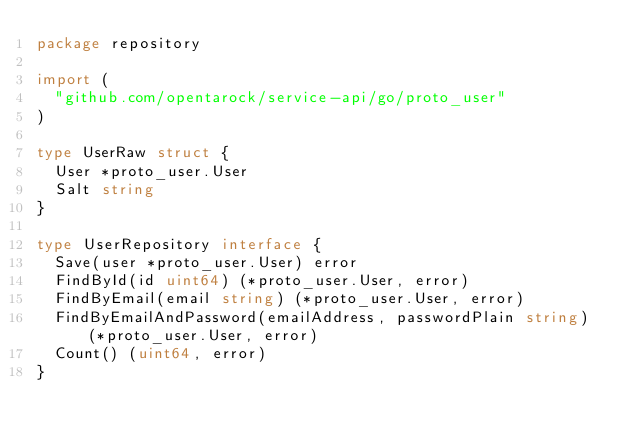Convert code to text. <code><loc_0><loc_0><loc_500><loc_500><_Go_>package repository

import (
	"github.com/opentarock/service-api/go/proto_user"
)

type UserRaw struct {
	User *proto_user.User
	Salt string
}

type UserRepository interface {
	Save(user *proto_user.User) error
	FindById(id uint64) (*proto_user.User, error)
	FindByEmail(email string) (*proto_user.User, error)
	FindByEmailAndPassword(emailAddress, passwordPlain string) (*proto_user.User, error)
	Count() (uint64, error)
}
</code> 